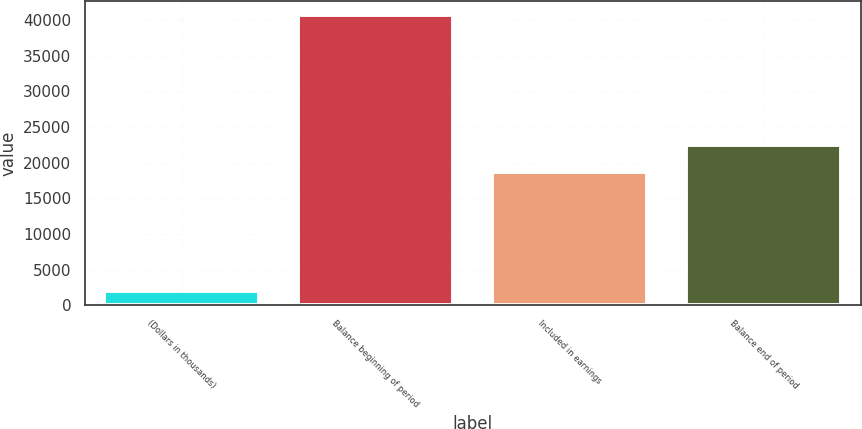Convert chart. <chart><loc_0><loc_0><loc_500><loc_500><bar_chart><fcel>(Dollars in thousands)<fcel>Balance beginning of period<fcel>Included in earnings<fcel>Balance end of period<nl><fcel>2016<fcel>40705<fcel>18646<fcel>22514.9<nl></chart> 